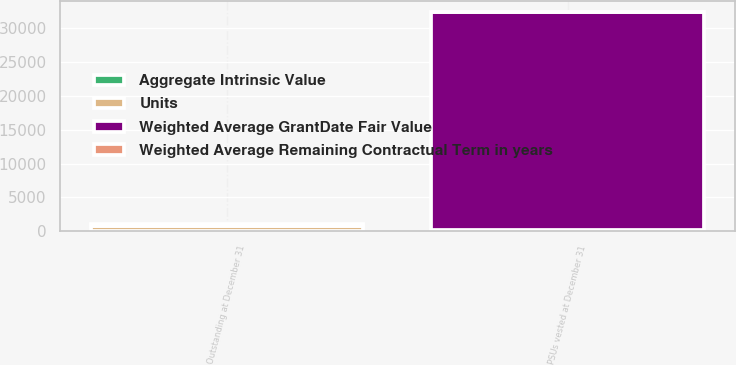Convert chart. <chart><loc_0><loc_0><loc_500><loc_500><stacked_bar_chart><ecel><fcel>Outstanding at December 31<fcel>PSUs vested at December 31<nl><fcel>Units<fcel>857<fcel>224<nl><fcel>Weighted Average Remaining Contractual Term in years<fcel>136<fcel>132<nl><fcel>Aggregate Intrinsic Value<fcel>1.5<fcel>1.5<nl><fcel>Weighted Average GrantDate Fair Value<fcel>136<fcel>32083<nl></chart> 